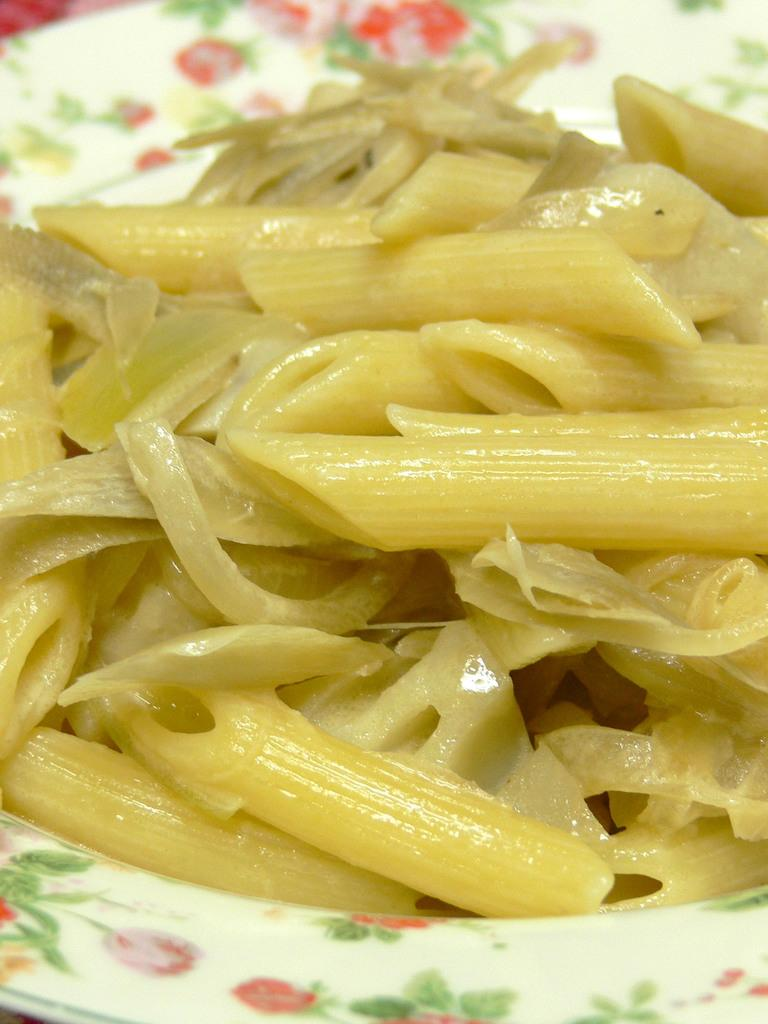What type of food is visible in the image? There is cooked pasta in the image. How is the cooked pasta presented in the image? The cooked pasta is served in a plate. What type of power source is visible in the image? There is no power source visible in the image; it features cooked pasta served in a plate. What type of clover can be seen growing in the image? There is no clover present in the image. 